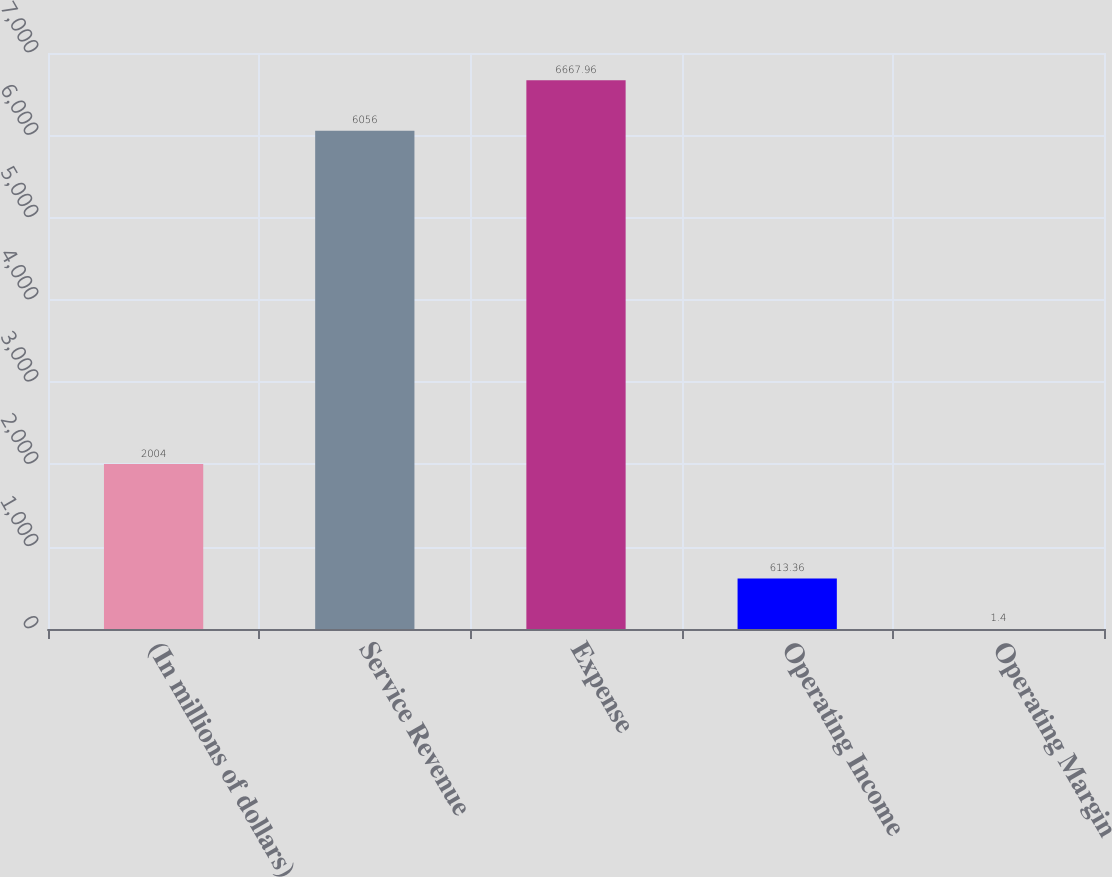<chart> <loc_0><loc_0><loc_500><loc_500><bar_chart><fcel>(In millions of dollars)<fcel>Service Revenue<fcel>Expense<fcel>Operating Income<fcel>Operating Margin<nl><fcel>2004<fcel>6056<fcel>6667.96<fcel>613.36<fcel>1.4<nl></chart> 